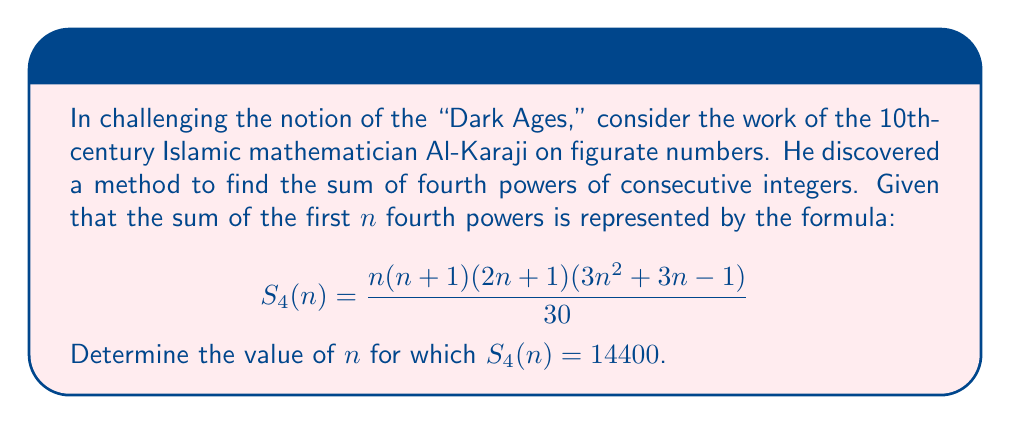Can you answer this question? To solve this problem, we need to set up an equation using the given formula and solve for $n$:

$$\frac{n(n+1)(2n+1)(3n^2+3n-1)}{30} = 14400$$

Multiply both sides by 30:

$$n(n+1)(2n+1)(3n^2+3n-1) = 432000$$

This is a 5th-degree polynomial equation, which is not easily solvable by factoring or common algebraic methods. However, given the context of figurate numbers and the work of medieval Islamic mathematicians, we can infer that the solution is likely to be a positive integer.

Let's try some integer values:

For $n = 5$:
$5 \cdot 6 \cdot 11 \cdot 89 = 29370 < 432000$

For $n = 6$:
$6 \cdot 7 \cdot 13 \cdot 125 = 68250 < 432000$

For $n = 7$:
$7 \cdot 8 \cdot 15 \cdot 167 = 140280 < 432000$

For $n = 8$:
$8 \cdot 9 \cdot 17 \cdot 215 = 262440 < 432000$

For $n = 9$:
$9 \cdot 10 \cdot 19 \cdot 269 = 432000$

Therefore, we find that $n = 9$ satisfies the equation.

To verify:
$$S_4(9) = \frac{9(9+1)(2\cdot9+1)(3\cdot9^2+3\cdot9-1)}{30} = \frac{9 \cdot 10 \cdot 19 \cdot 269}{30} = 14400$$

This problem showcases the advanced mathematical thinking of medieval Islamic scholars, contradicting the notion of intellectual stagnation during the so-called "Dark Ages."
Answer: $n = 9$ 